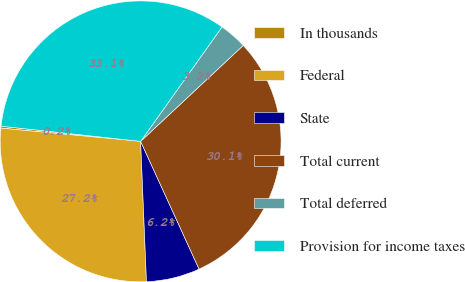Convert chart to OTSL. <chart><loc_0><loc_0><loc_500><loc_500><pie_chart><fcel>In thousands<fcel>Federal<fcel>State<fcel>Total current<fcel>Total deferred<fcel>Provision for income taxes<nl><fcel>0.22%<fcel>27.17%<fcel>6.17%<fcel>30.14%<fcel>3.19%<fcel>33.12%<nl></chart> 